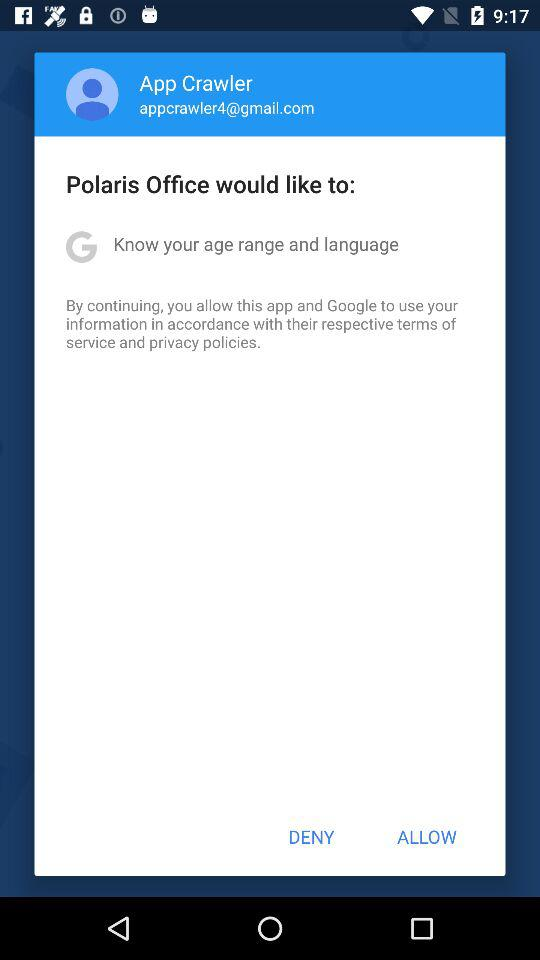What would Polaris Office like to do? The Polaris Office would like to "Know your age range and language". 